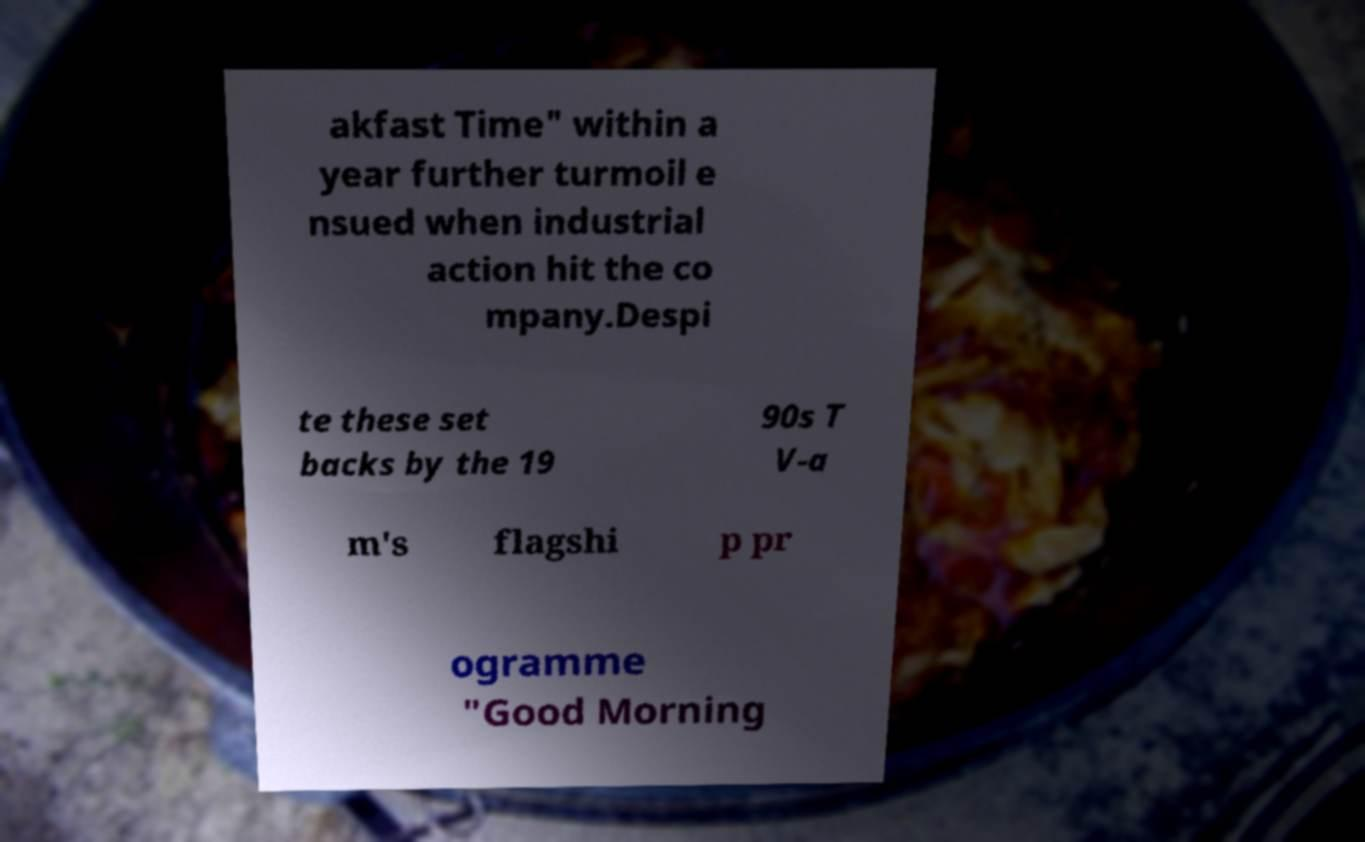Can you read and provide the text displayed in the image?This photo seems to have some interesting text. Can you extract and type it out for me? akfast Time" within a year further turmoil e nsued when industrial action hit the co mpany.Despi te these set backs by the 19 90s T V-a m's flagshi p pr ogramme "Good Morning 